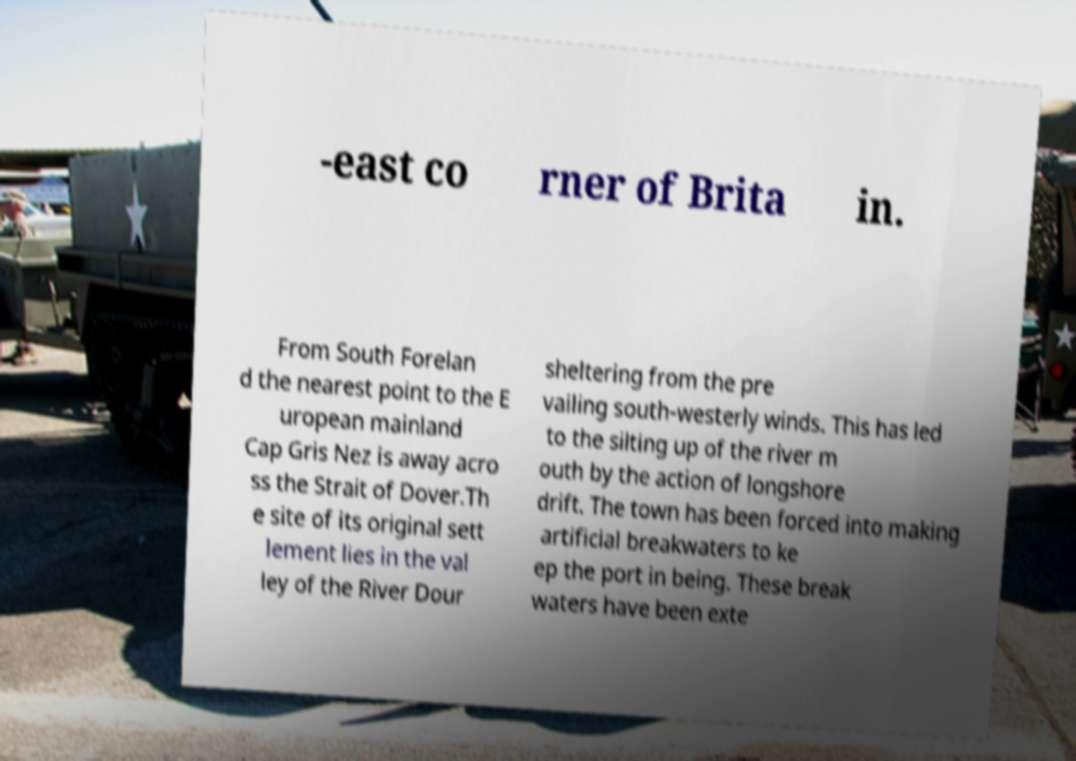Can you read and provide the text displayed in the image?This photo seems to have some interesting text. Can you extract and type it out for me? -east co rner of Brita in. From South Forelan d the nearest point to the E uropean mainland Cap Gris Nez is away acro ss the Strait of Dover.Th e site of its original sett lement lies in the val ley of the River Dour sheltering from the pre vailing south-westerly winds. This has led to the silting up of the river m outh by the action of longshore drift. The town has been forced into making artificial breakwaters to ke ep the port in being. These break waters have been exte 